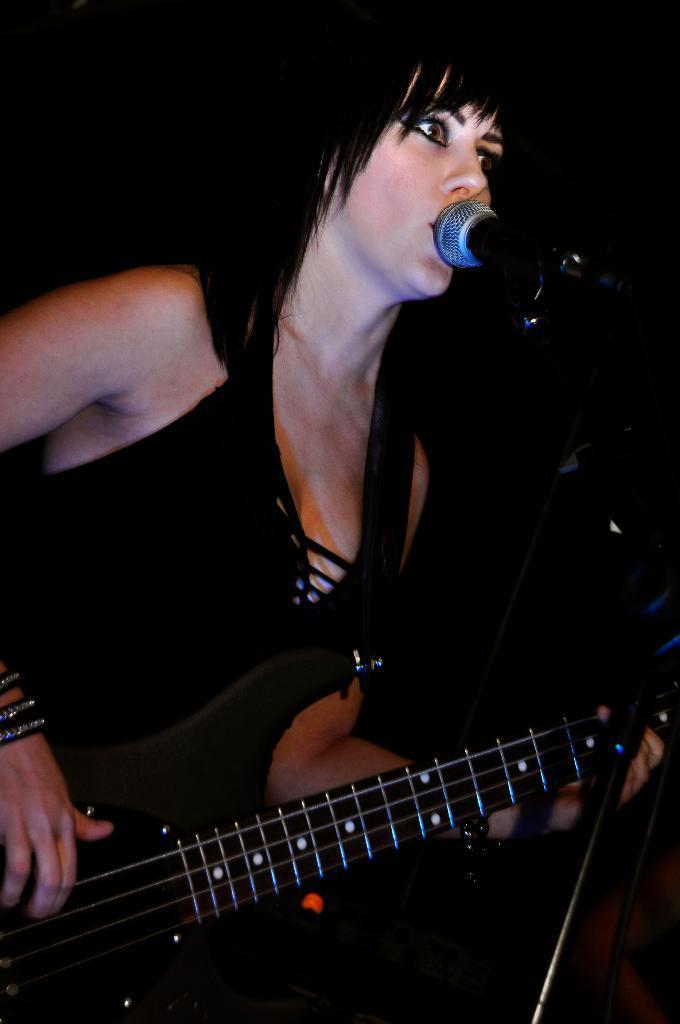Can you describe this image briefly? A lady with black dress is standing and playing guitar. In front of her there is a mic. 